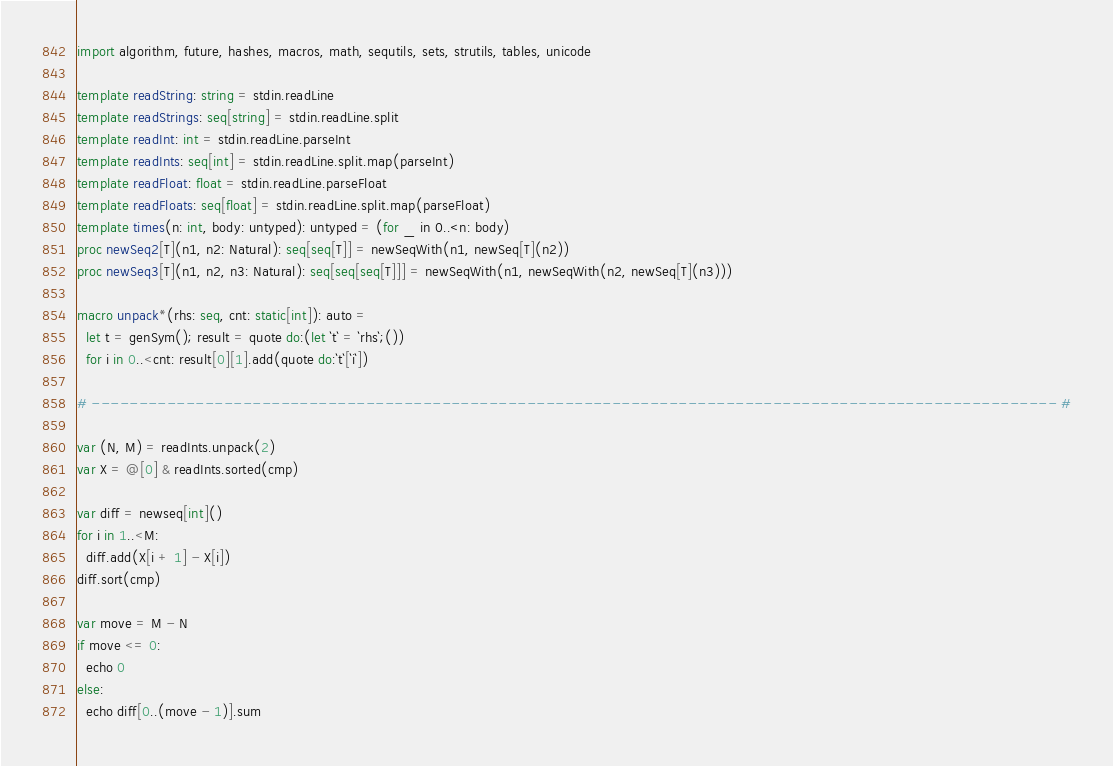Convert code to text. <code><loc_0><loc_0><loc_500><loc_500><_Nim_>import algorithm, future, hashes, macros, math, sequtils, sets, strutils, tables, unicode

template readString: string = stdin.readLine
template readStrings: seq[string] = stdin.readLine.split
template readInt: int = stdin.readLine.parseInt
template readInts: seq[int] = stdin.readLine.split.map(parseInt)
template readFloat: float = stdin.readLine.parseFloat
template readFloats: seq[float] = stdin.readLine.split.map(parseFloat)
template times(n: int, body: untyped): untyped = (for _ in 0..<n: body)
proc newSeq2[T](n1, n2: Natural): seq[seq[T]] = newSeqWith(n1, newSeq[T](n2))
proc newSeq3[T](n1, n2, n3: Natural): seq[seq[seq[T]]] = newSeqWith(n1, newSeqWith(n2, newSeq[T](n3)))

macro unpack*(rhs: seq, cnt: static[int]): auto =
  let t = genSym(); result = quote do:(let `t` = `rhs`;())
  for i in 0..<cnt: result[0][1].add(quote do:`t`[`i`])

# ------------------------------------------------------------------------------------------------------ #

var (N, M) = readInts.unpack(2)
var X = @[0] & readInts.sorted(cmp)

var diff = newseq[int]()
for i in 1..<M:
  diff.add(X[i + 1] - X[i])
diff.sort(cmp)

var move = M - N
if move <= 0:
  echo 0
else:
  echo diff[0..(move - 1)].sum
</code> 